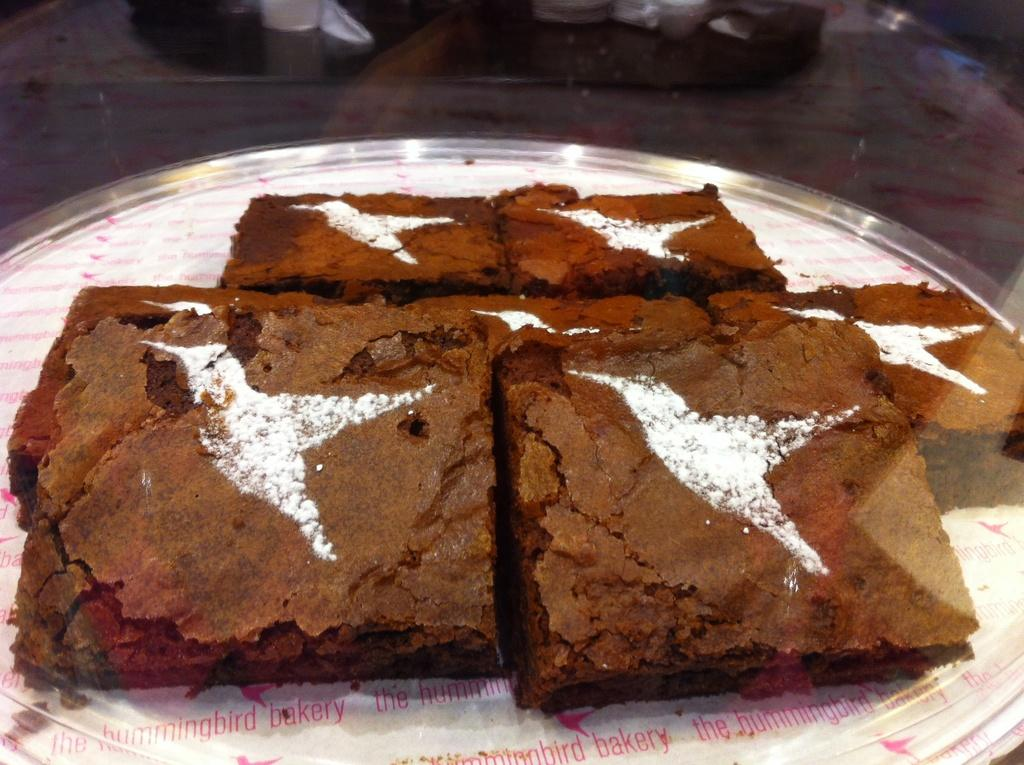What can be seen on the surface in the image? There are food items on a surface in the image. What type of container is present in the image? There is a glass in the image. Can you describe the background of the image? There are objects visible in the background of the image. What verse is being recited in the image? There is no verse being recited in the image; it features food items, a glass, and objects in the background. 